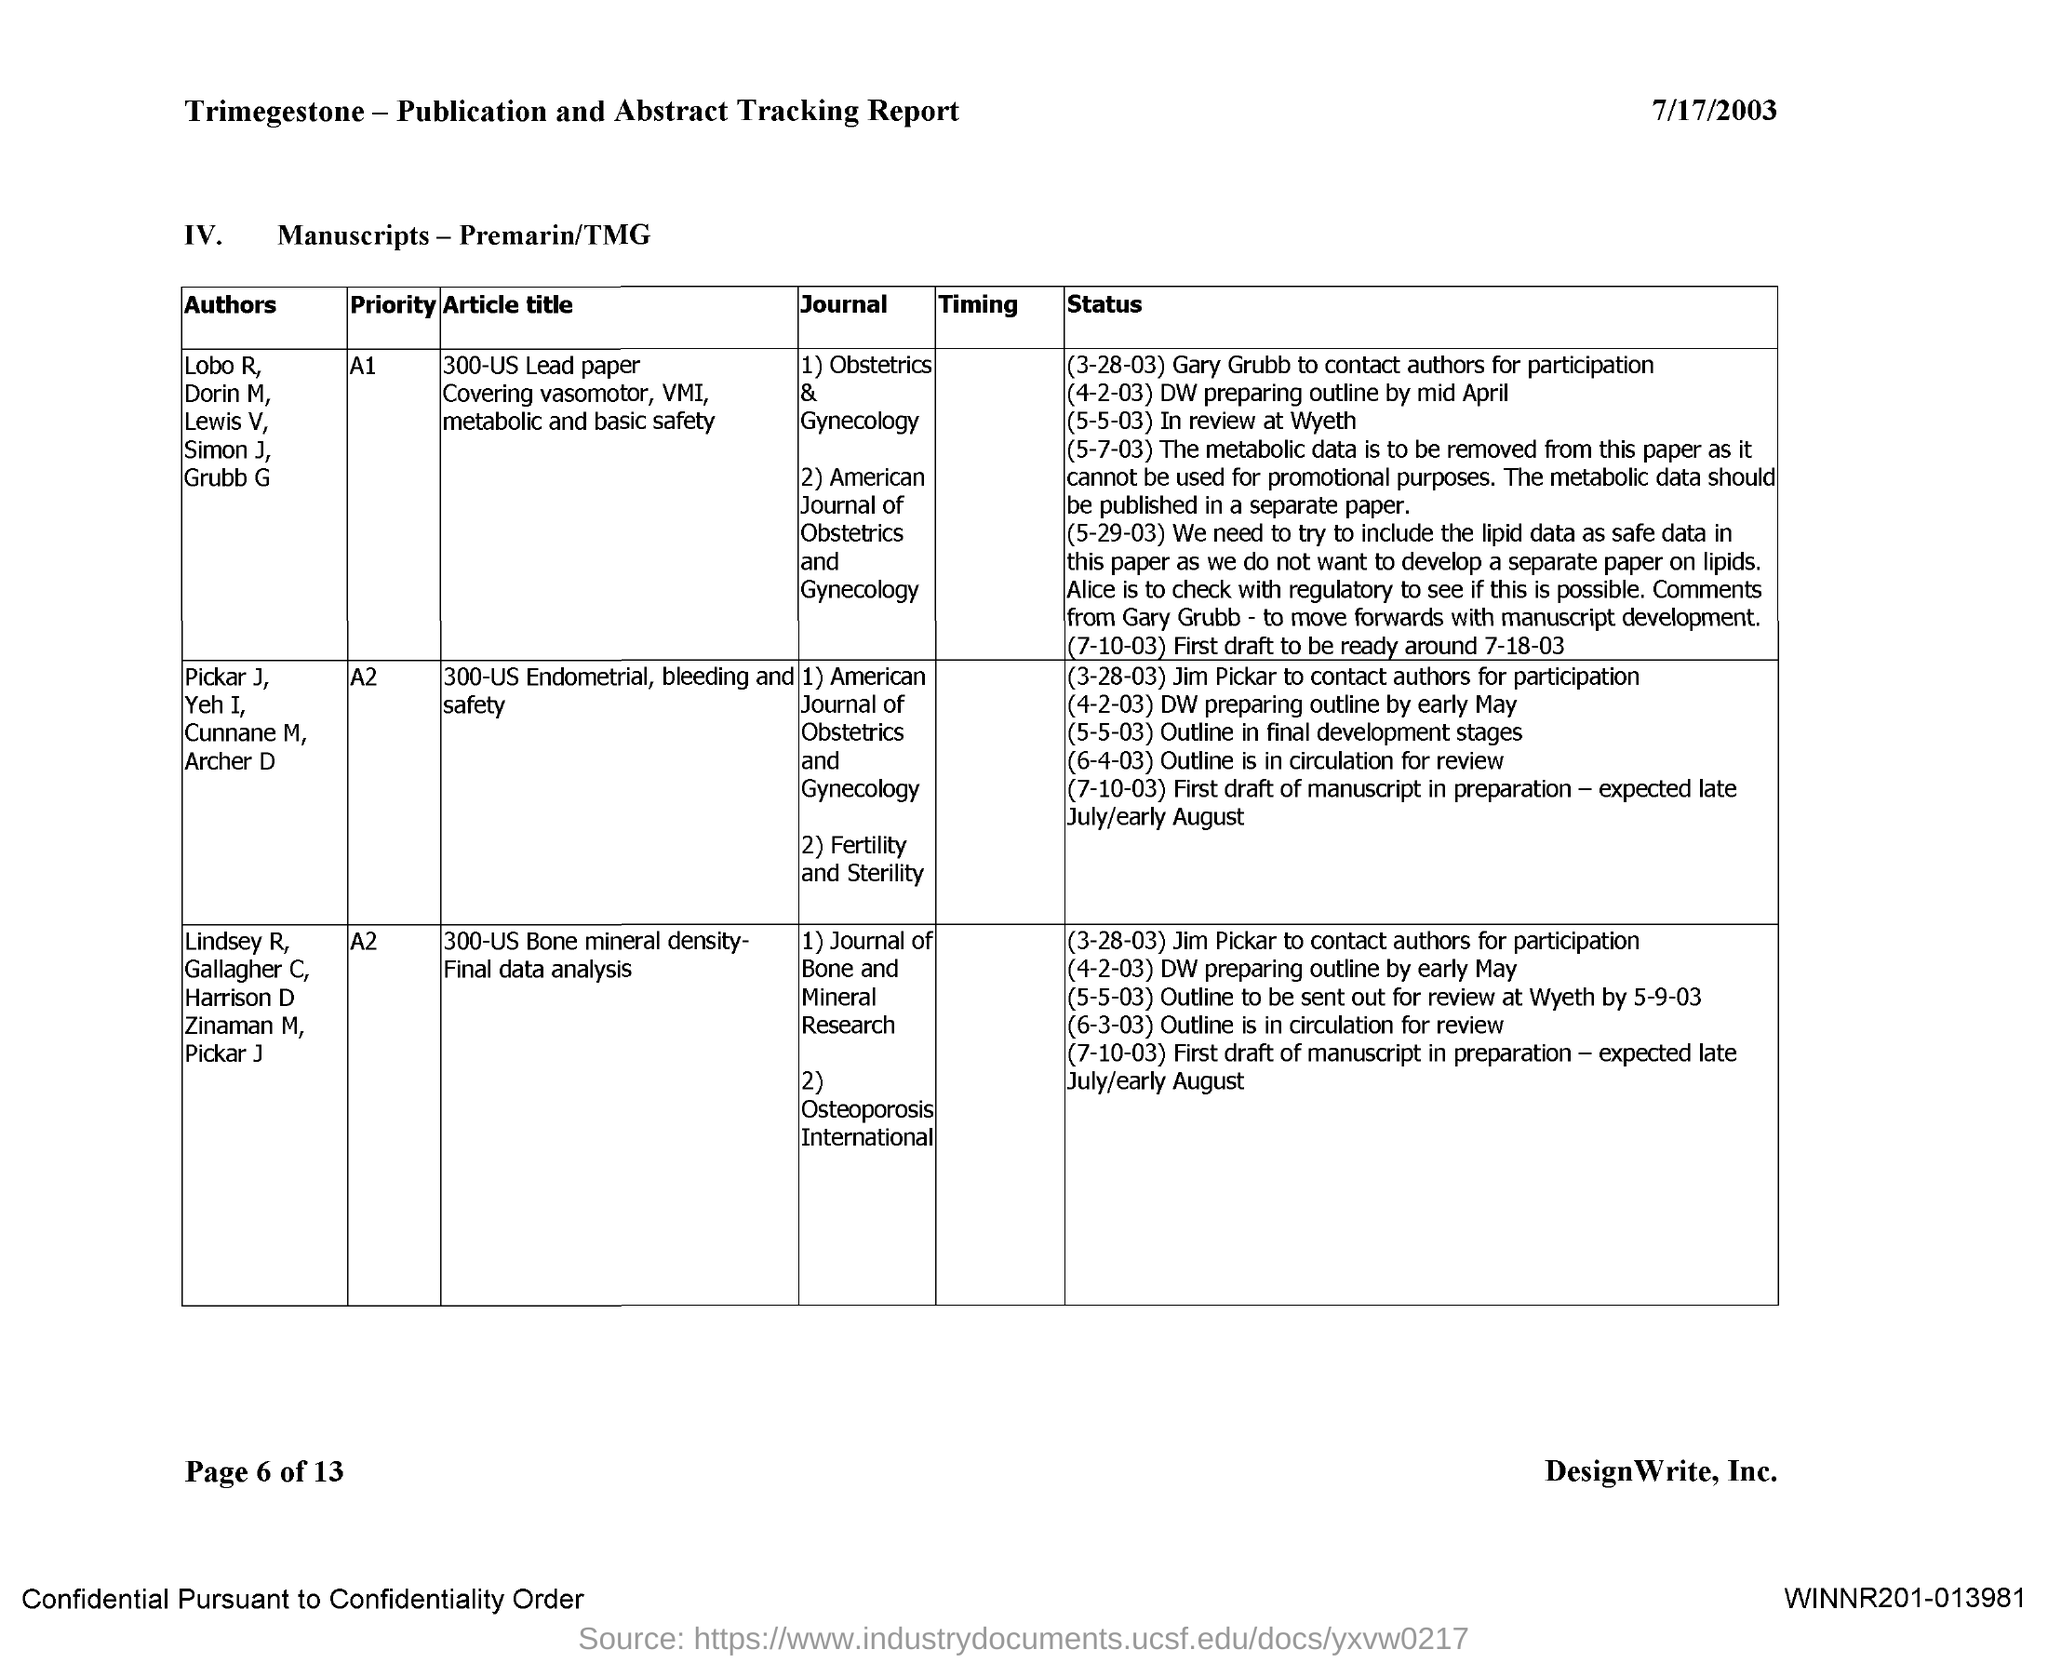When is the document dated?
Your answer should be compact. 7/17/2003. 